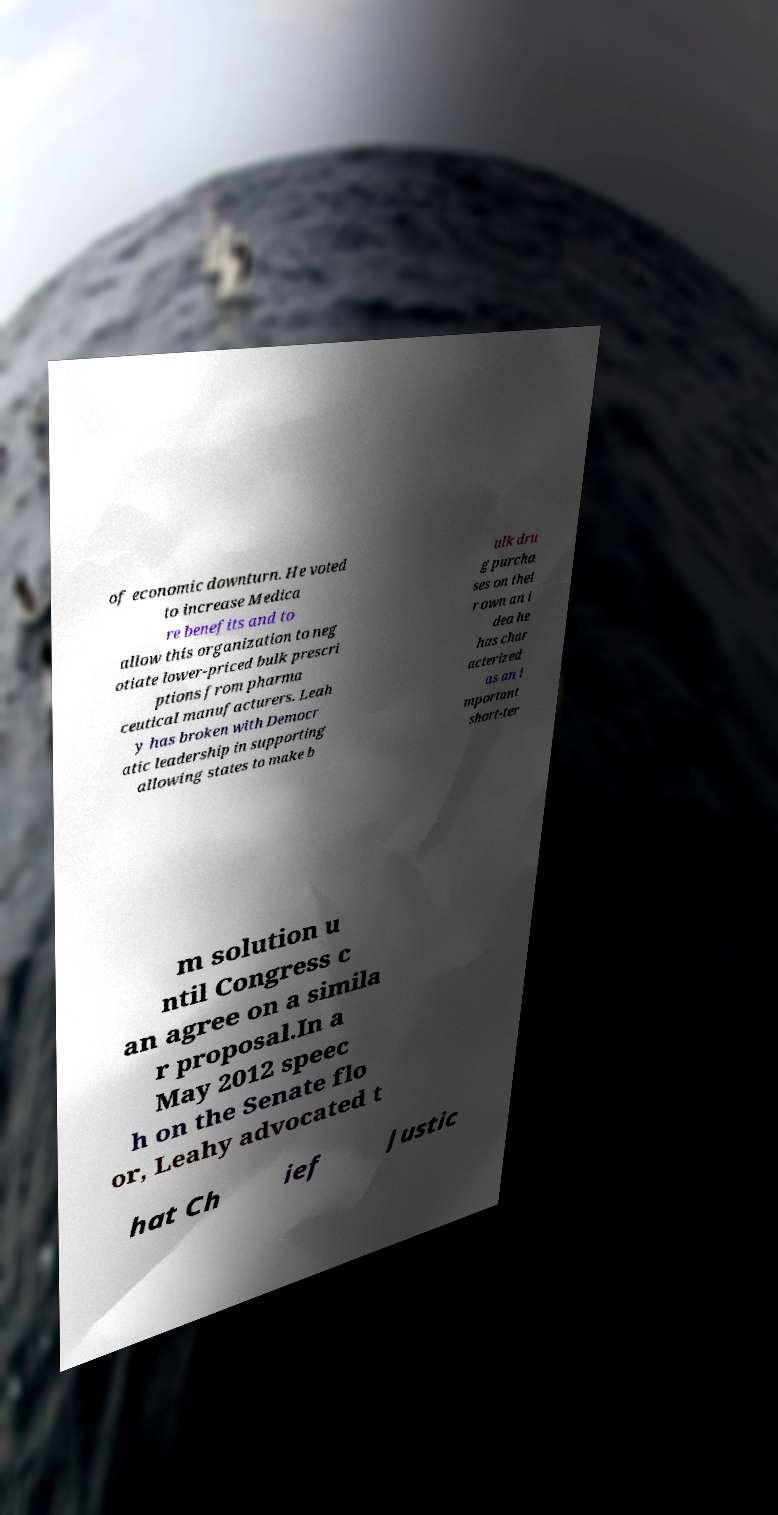For documentation purposes, I need the text within this image transcribed. Could you provide that? of economic downturn. He voted to increase Medica re benefits and to allow this organization to neg otiate lower-priced bulk prescri ptions from pharma ceutical manufacturers. Leah y has broken with Democr atic leadership in supporting allowing states to make b ulk dru g purcha ses on thei r own an i dea he has char acterized as an i mportant short-ter m solution u ntil Congress c an agree on a simila r proposal.In a May 2012 speec h on the Senate flo or, Leahy advocated t hat Ch ief Justic 